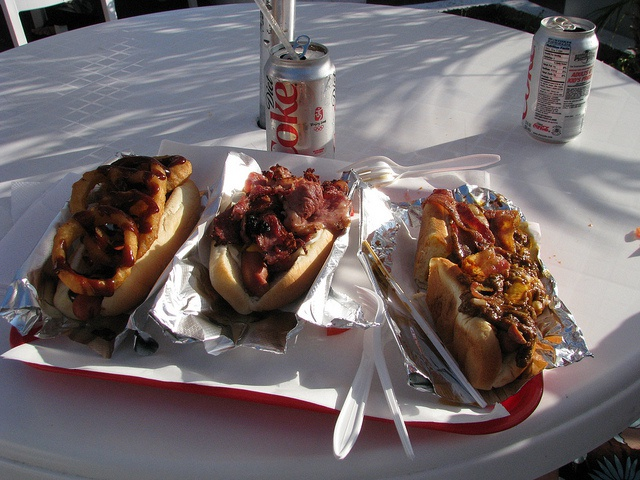Describe the objects in this image and their specific colors. I can see dining table in gray, darkgray, black, and maroon tones, hot dog in gray, maroon, black, and brown tones, hot dog in gray, black, maroon, and brown tones, hot dog in gray, black, maroon, and brown tones, and chair in gray, black, and lightgray tones in this image. 